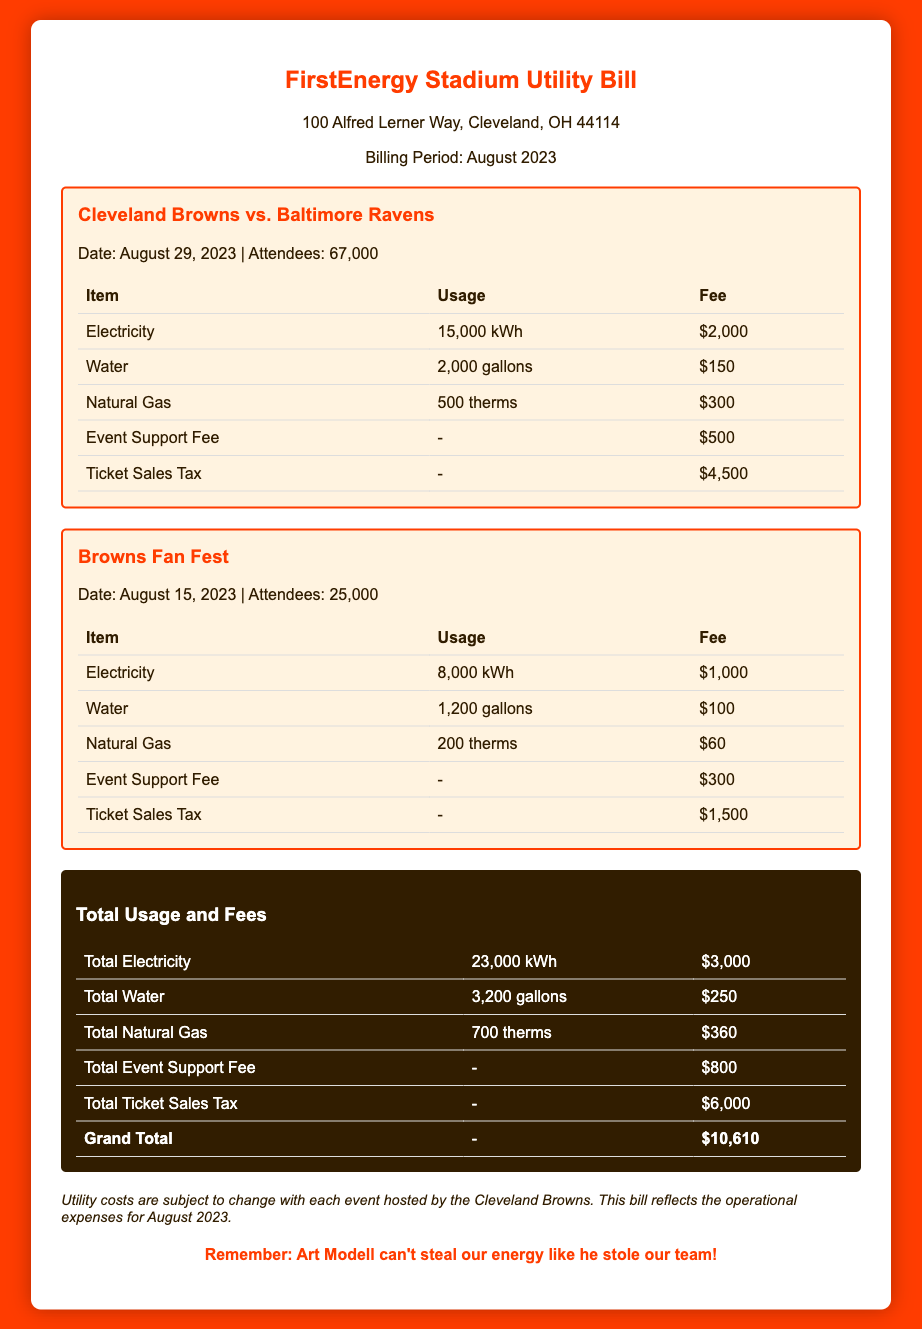what is the date of the Cleveland Browns vs. Baltimore Ravens event? The date is specified in the event details section of the document.
Answer: August 29, 2023 how many attendees were at the Browns Fan Fest? The number of attendees is listed under the event details for Browns Fan Fest.
Answer: 25,000 what is the total fee for electricity used? The total fee for electricity is the sum of the electricity fees for both events.
Answer: $3,000 how much was collected in ticket sales tax? The document details the fee for ticket sales tax separately for both events.
Answer: $6,000 what is the fee for the Event Support Fee for both events? The Event Support Fee is listed under each event and needs to be totaled.
Answer: $800 how many gallons of water were used during the Cleveland Browns vs. Baltimore Ravens event? The water usage is specified in the section related to that event.
Answer: 2,000 gallons what is the Grand Total for the utility bill? The Grand Total is provided at the end of the totals section.
Answer: $10,610 what is the natural gas fee for the Browns Fan Fest? The fee for natural gas is included in the table for that event.
Answer: $60 is there a note regarding the utility costs? The document includes a note about the variability of utility costs based on events.
Answer: Yes 